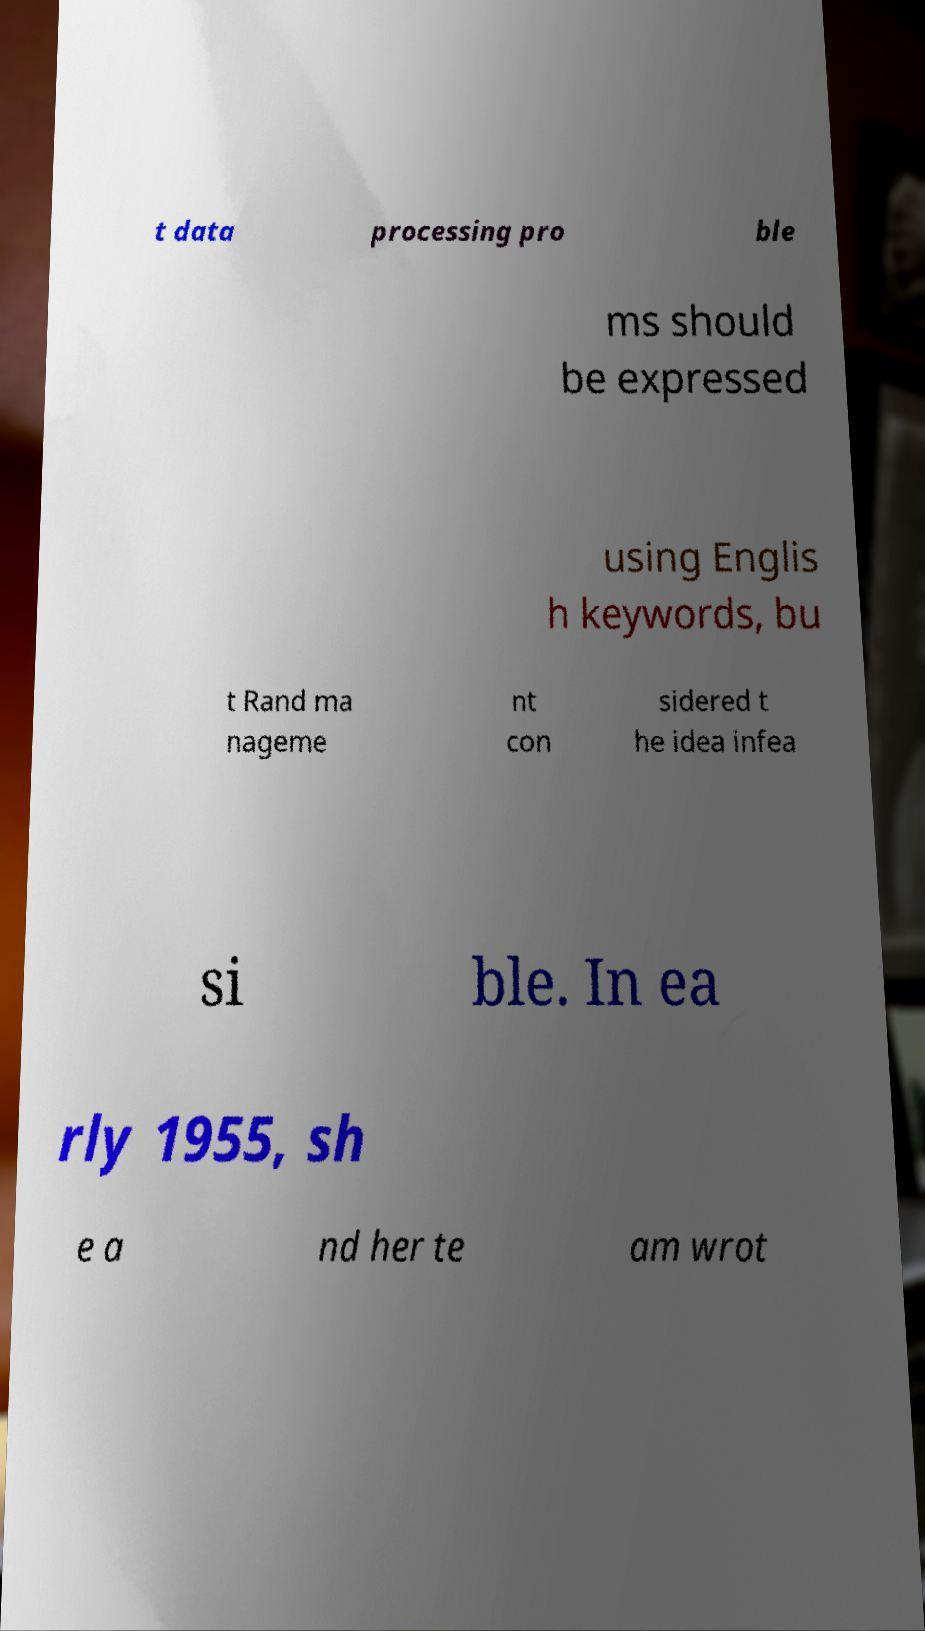There's text embedded in this image that I need extracted. Can you transcribe it verbatim? t data processing pro ble ms should be expressed using Englis h keywords, bu t Rand ma nageme nt con sidered t he idea infea si ble. In ea rly 1955, sh e a nd her te am wrot 